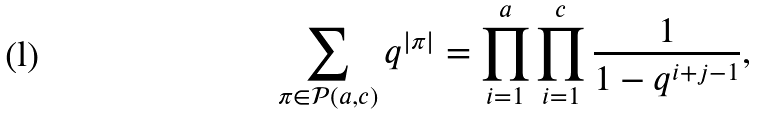<formula> <loc_0><loc_0><loc_500><loc_500>\sum _ { \pi \in \mathcal { P } ( a , c ) } q ^ { | \pi | } = \prod _ { i = 1 } ^ { a } \prod _ { i = 1 } ^ { c } \frac { 1 } { 1 - q ^ { i + j - 1 } } ,</formula> 